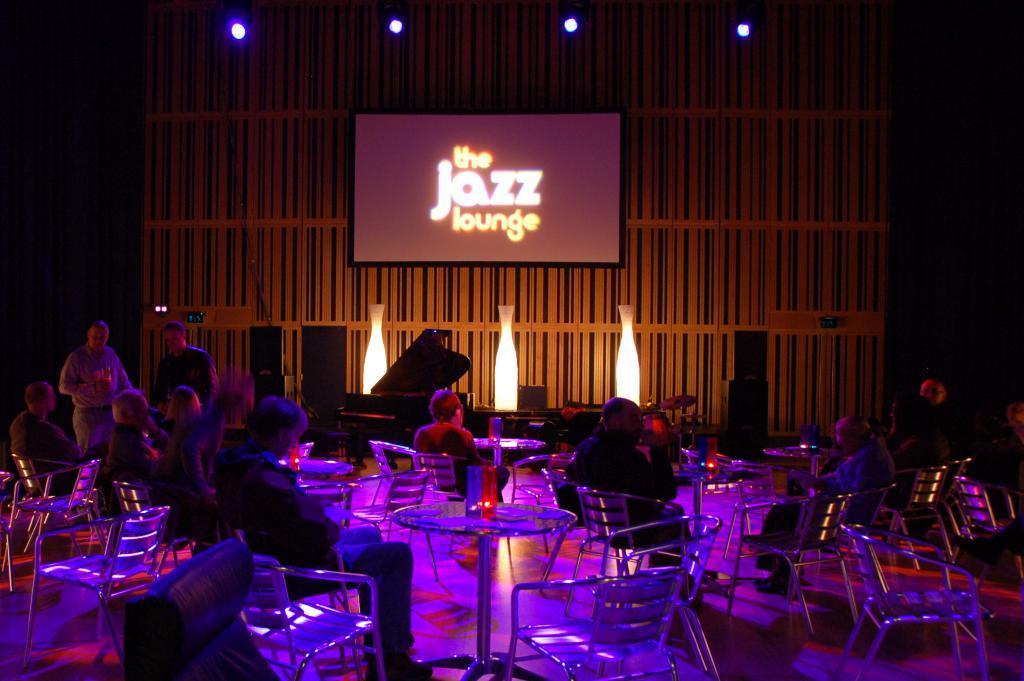Could you give a brief overview of what you see in this image? in this picture there are people sitting they have a table in front of them, there are empty chairs and light attached to the ceiling and there is a television attached to the wall. 